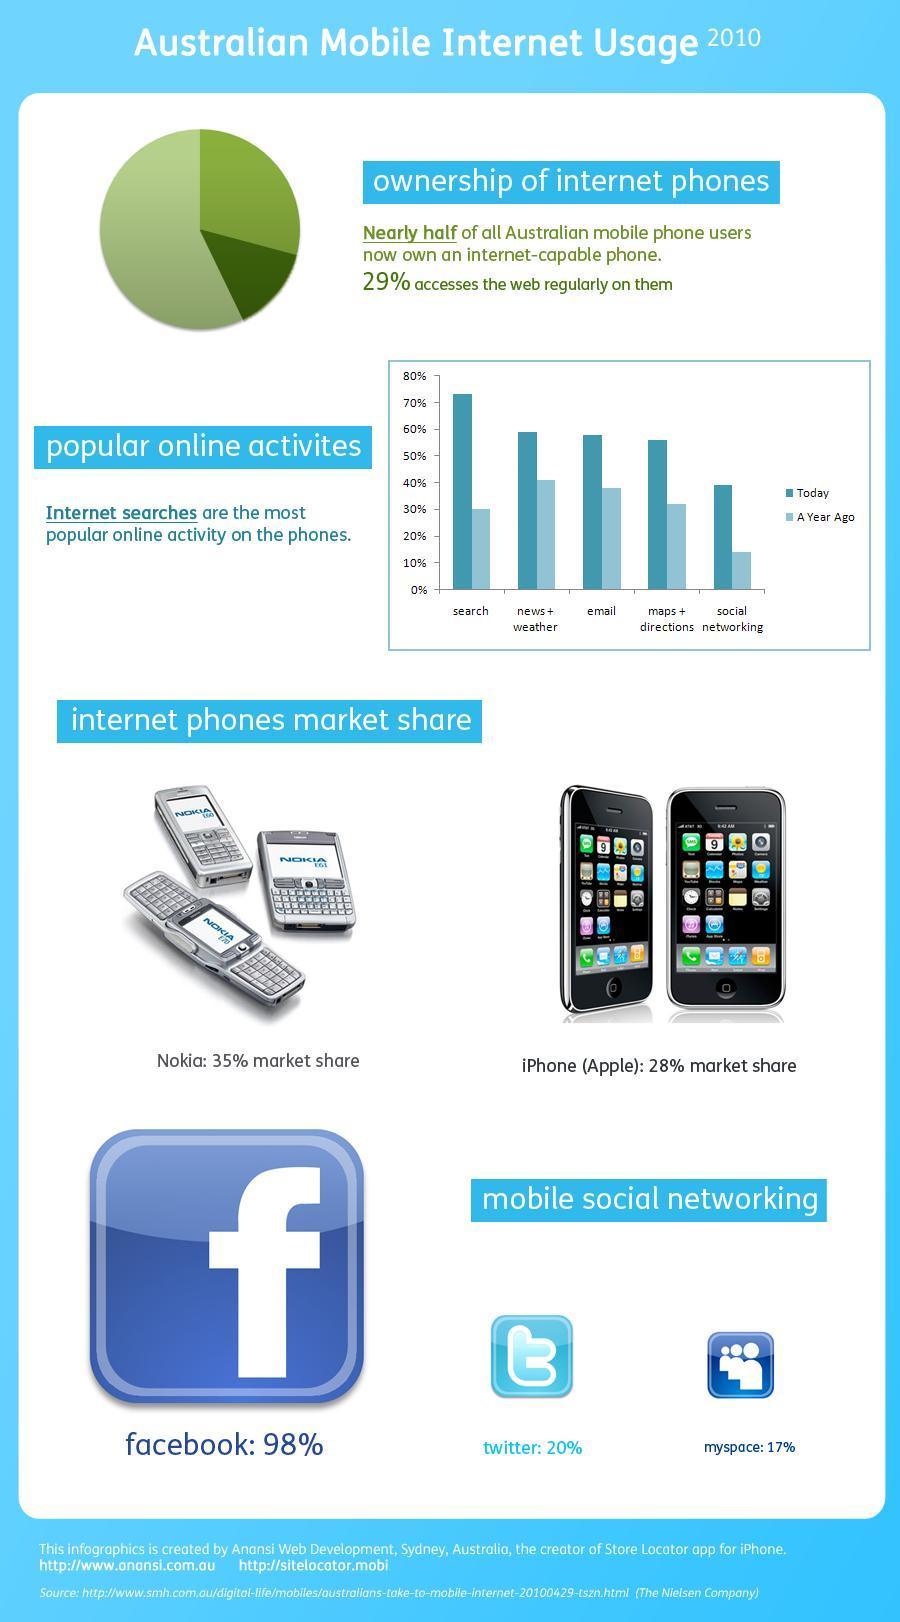Which mobile social networking site contributes to highest market share in Australia in the year 2010?
Answer the question with a short phrase. facebook Which is the least popular online activity on the phones in the year 2010? social networking Which mobile social networking site contributes to lowest market share in Australia in the year 2010? myspace Which brand phone has the highest market share in Australia in the year 2010? Nokia 